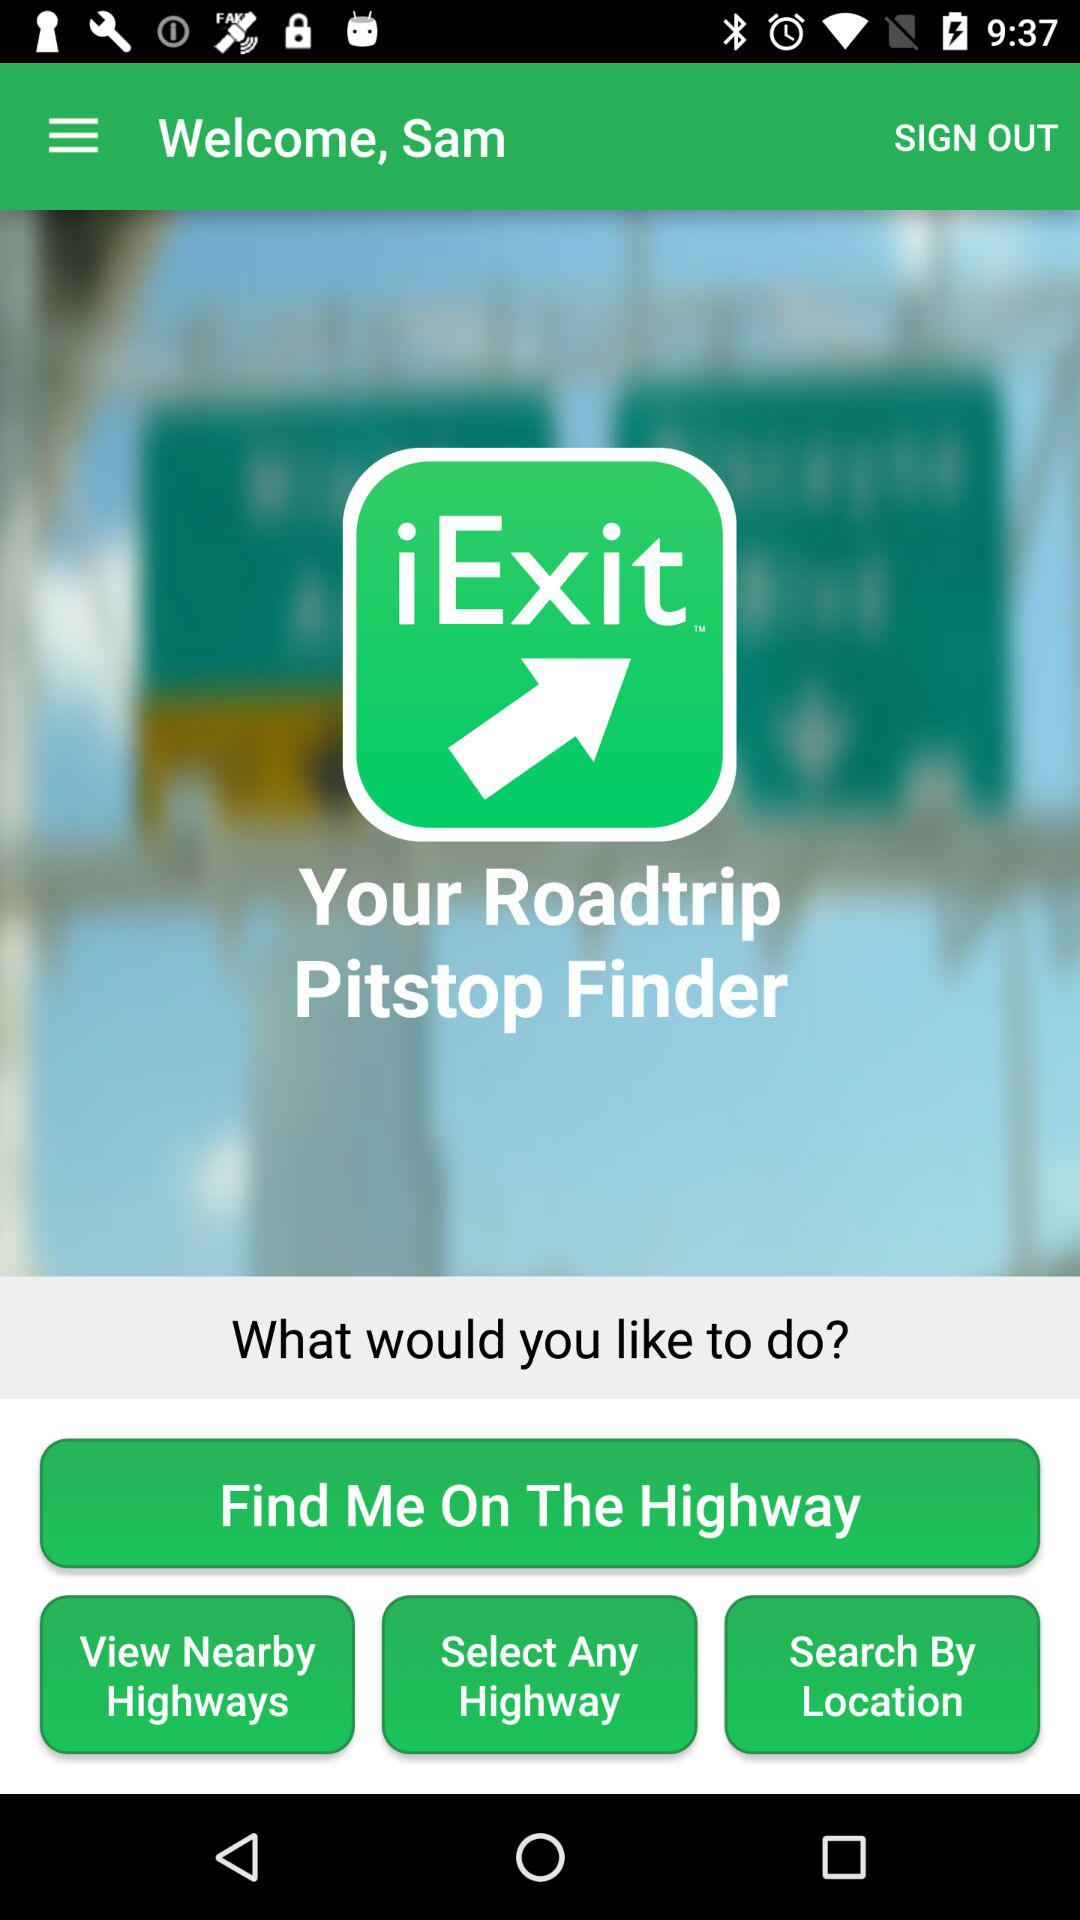What is the name of the application? The application name is "iExit". 